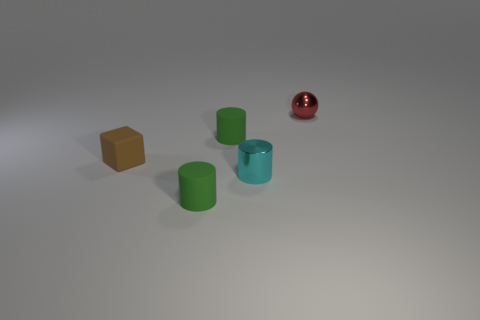Add 3 shiny cylinders. How many objects exist? 8 Subtract all balls. How many objects are left? 4 Subtract all small cyan things. Subtract all tiny brown matte blocks. How many objects are left? 3 Add 3 small red balls. How many small red balls are left? 4 Add 3 red cubes. How many red cubes exist? 3 Subtract 0 blue cubes. How many objects are left? 5 